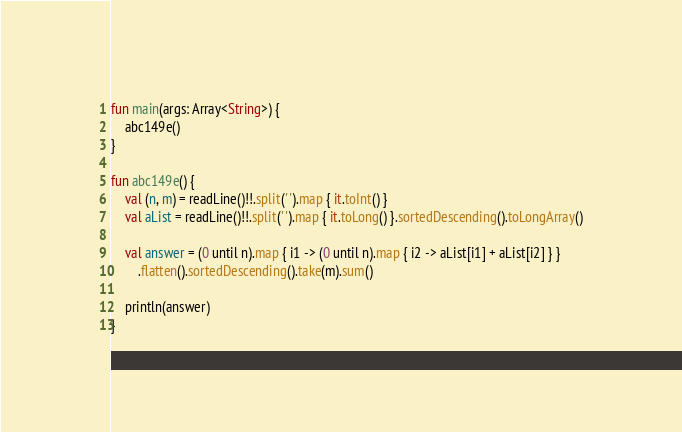Convert code to text. <code><loc_0><loc_0><loc_500><loc_500><_Kotlin_>fun main(args: Array<String>) {
    abc149e()
}

fun abc149e() {
    val (n, m) = readLine()!!.split(' ').map { it.toInt() }
    val aList = readLine()!!.split(' ').map { it.toLong() }.sortedDescending().toLongArray()

    val answer = (0 until n).map { i1 -> (0 until n).map { i2 -> aList[i1] + aList[i2] } }
        .flatten().sortedDescending().take(m).sum()

    println(answer)
}
</code> 